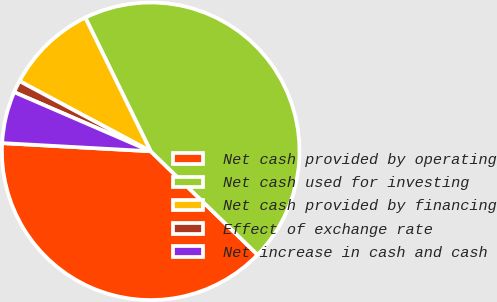Convert chart. <chart><loc_0><loc_0><loc_500><loc_500><pie_chart><fcel>Net cash provided by operating<fcel>Net cash used for investing<fcel>Net cash provided by financing<fcel>Effect of exchange rate<fcel>Net increase in cash and cash<nl><fcel>38.63%<fcel>44.49%<fcel>9.94%<fcel>1.31%<fcel>5.63%<nl></chart> 